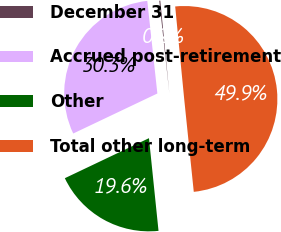Convert chart. <chart><loc_0><loc_0><loc_500><loc_500><pie_chart><fcel>December 31<fcel>Accrued post-retirement<fcel>Other<fcel>Total other long-term<nl><fcel>0.18%<fcel>30.34%<fcel>19.57%<fcel>49.91%<nl></chart> 